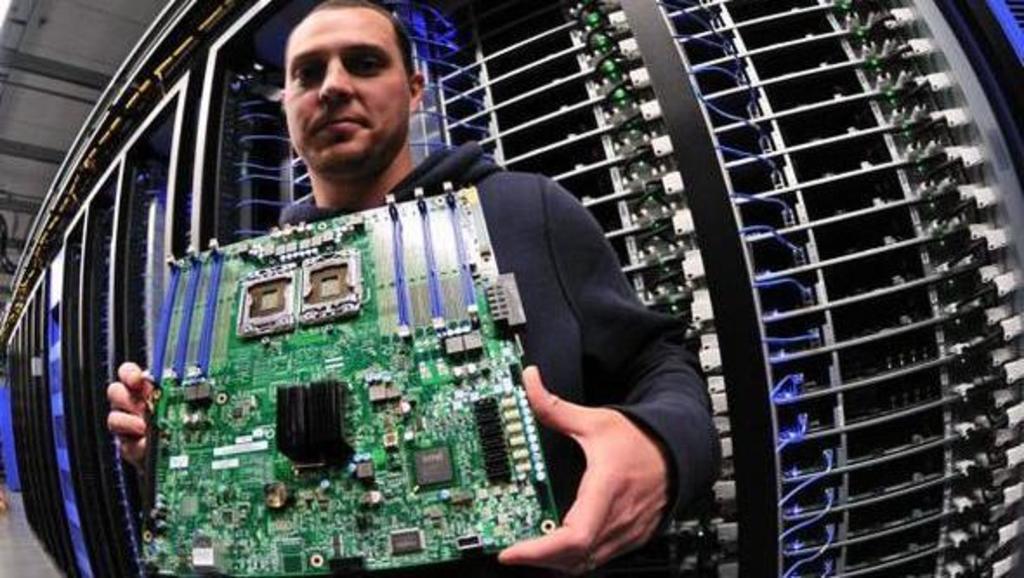How would you summarize this image in a sentence or two? In this image I can see the person holding the chipboard. In the background I can see the data-center. 